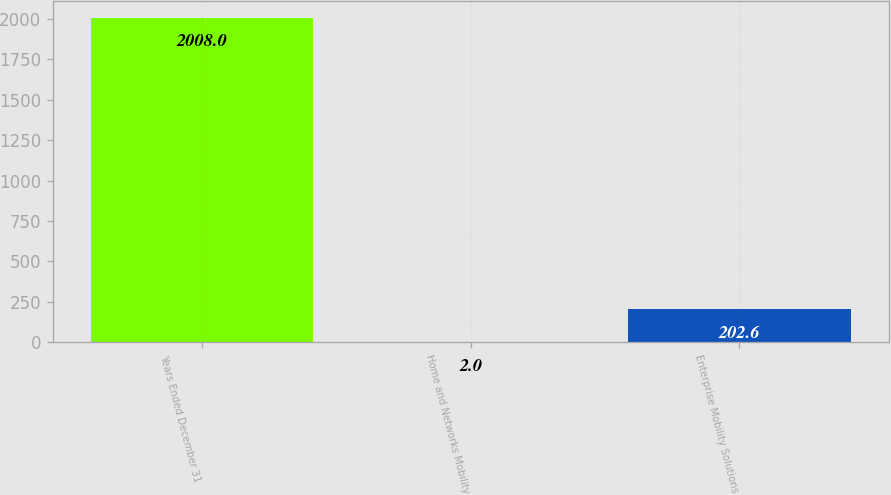Convert chart to OTSL. <chart><loc_0><loc_0><loc_500><loc_500><bar_chart><fcel>Years Ended December 31<fcel>Home and Networks Mobility<fcel>Enterprise Mobility Solutions<nl><fcel>2008<fcel>2<fcel>202.6<nl></chart> 